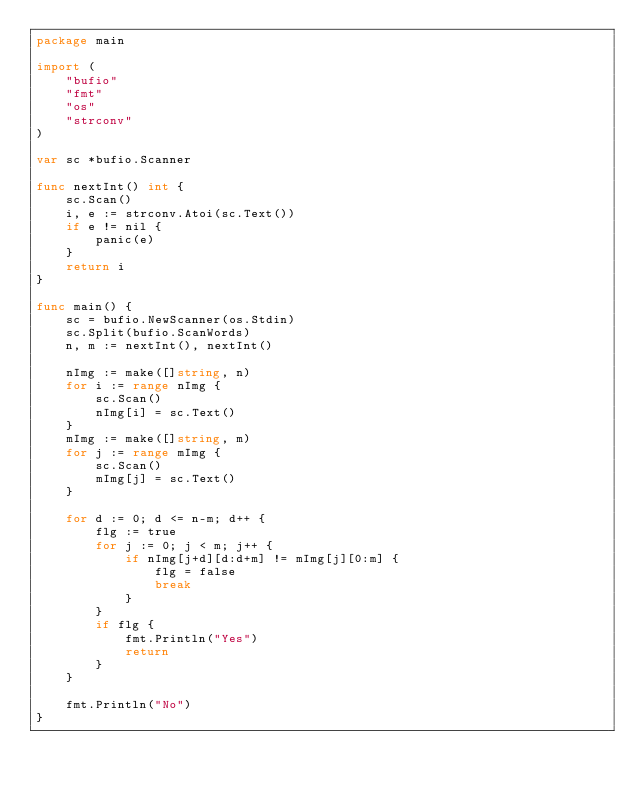Convert code to text. <code><loc_0><loc_0><loc_500><loc_500><_Go_>package main

import (
	"bufio"
	"fmt"
	"os"
	"strconv"
)

var sc *bufio.Scanner

func nextInt() int {
	sc.Scan()
	i, e := strconv.Atoi(sc.Text())
	if e != nil {
		panic(e)
	}
	return i
}

func main() {
	sc = bufio.NewScanner(os.Stdin)
	sc.Split(bufio.ScanWords)
	n, m := nextInt(), nextInt()

	nImg := make([]string, n)
	for i := range nImg {
		sc.Scan()
		nImg[i] = sc.Text()
	}
	mImg := make([]string, m)
	for j := range mImg {
		sc.Scan()
		mImg[j] = sc.Text()
	}

	for d := 0; d <= n-m; d++ {
		flg := true
		for j := 0; j < m; j++ {
			if nImg[j+d][d:d+m] != mImg[j][0:m] {
				flg = false
				break
			}
		}
		if flg {
			fmt.Println("Yes")
			return
		}
	}

	fmt.Println("No")
}
</code> 